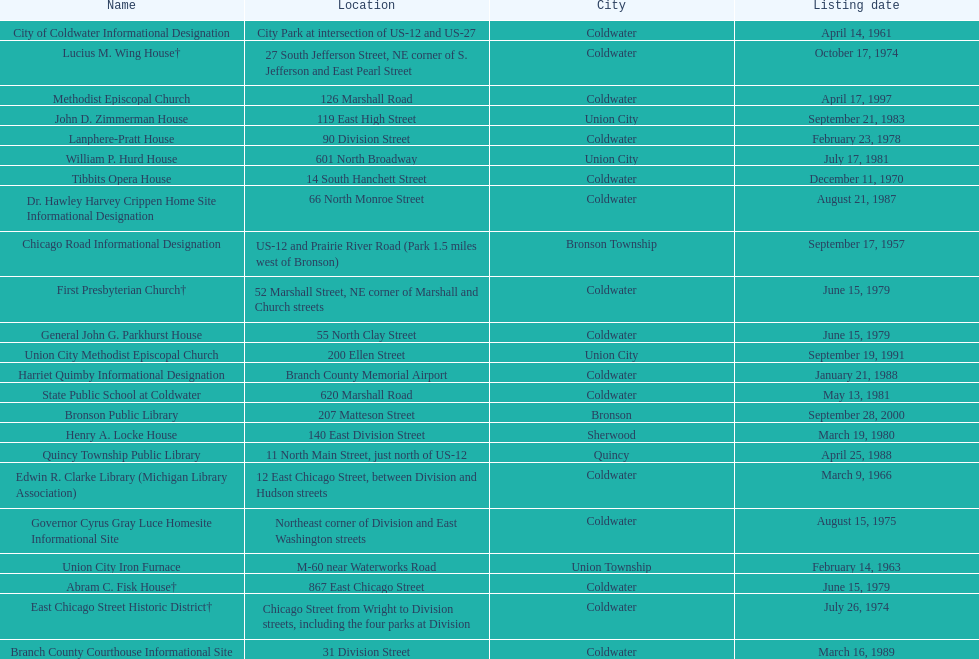What is the name with the only listing date on april 14, 1961 City of Coldwater. 